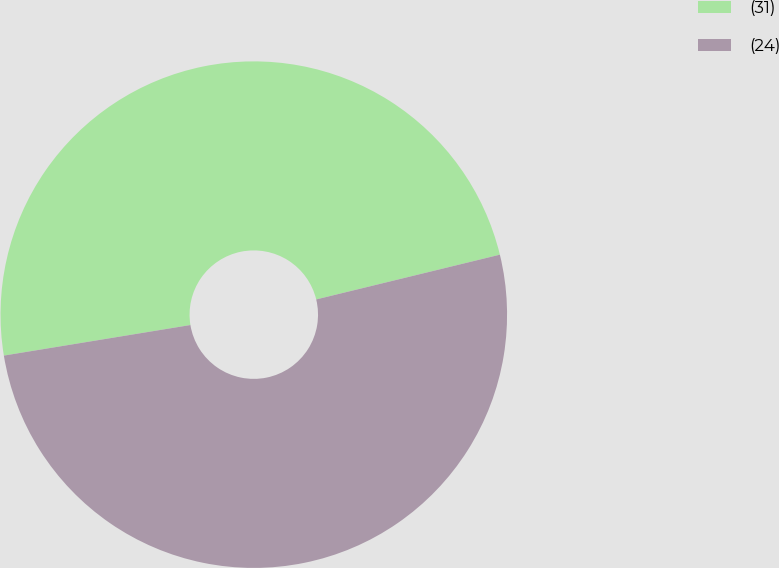<chart> <loc_0><loc_0><loc_500><loc_500><pie_chart><fcel>(31)<fcel>(24)<nl><fcel>48.78%<fcel>51.22%<nl></chart> 